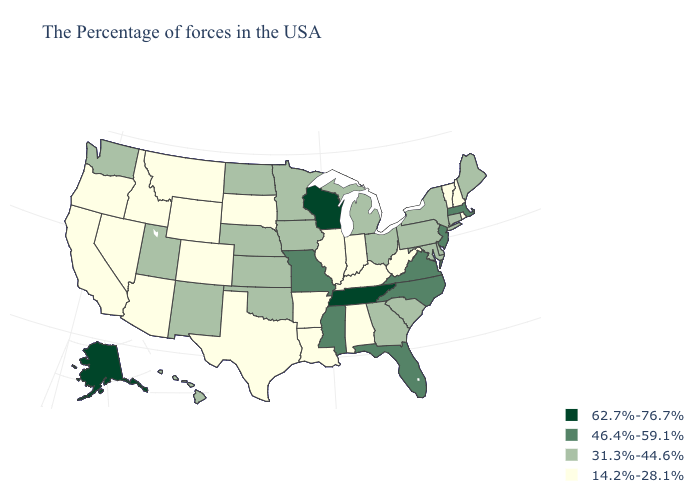What is the value of Ohio?
Quick response, please. 31.3%-44.6%. What is the value of Arizona?
Give a very brief answer. 14.2%-28.1%. Does Georgia have the highest value in the USA?
Answer briefly. No. What is the highest value in the Northeast ?
Be succinct. 46.4%-59.1%. Name the states that have a value in the range 31.3%-44.6%?
Short answer required. Maine, Connecticut, New York, Delaware, Maryland, Pennsylvania, South Carolina, Ohio, Georgia, Michigan, Minnesota, Iowa, Kansas, Nebraska, Oklahoma, North Dakota, New Mexico, Utah, Washington, Hawaii. Among the states that border Louisiana , which have the lowest value?
Be succinct. Arkansas, Texas. Name the states that have a value in the range 46.4%-59.1%?
Be succinct. Massachusetts, New Jersey, Virginia, North Carolina, Florida, Mississippi, Missouri. Name the states that have a value in the range 46.4%-59.1%?
Answer briefly. Massachusetts, New Jersey, Virginia, North Carolina, Florida, Mississippi, Missouri. Does Massachusetts have the lowest value in the USA?
Short answer required. No. Name the states that have a value in the range 31.3%-44.6%?
Keep it brief. Maine, Connecticut, New York, Delaware, Maryland, Pennsylvania, South Carolina, Ohio, Georgia, Michigan, Minnesota, Iowa, Kansas, Nebraska, Oklahoma, North Dakota, New Mexico, Utah, Washington, Hawaii. Name the states that have a value in the range 31.3%-44.6%?
Quick response, please. Maine, Connecticut, New York, Delaware, Maryland, Pennsylvania, South Carolina, Ohio, Georgia, Michigan, Minnesota, Iowa, Kansas, Nebraska, Oklahoma, North Dakota, New Mexico, Utah, Washington, Hawaii. Name the states that have a value in the range 14.2%-28.1%?
Keep it brief. Rhode Island, New Hampshire, Vermont, West Virginia, Kentucky, Indiana, Alabama, Illinois, Louisiana, Arkansas, Texas, South Dakota, Wyoming, Colorado, Montana, Arizona, Idaho, Nevada, California, Oregon. What is the highest value in the MidWest ?
Answer briefly. 62.7%-76.7%. Is the legend a continuous bar?
Be succinct. No. What is the value of Washington?
Be succinct. 31.3%-44.6%. 